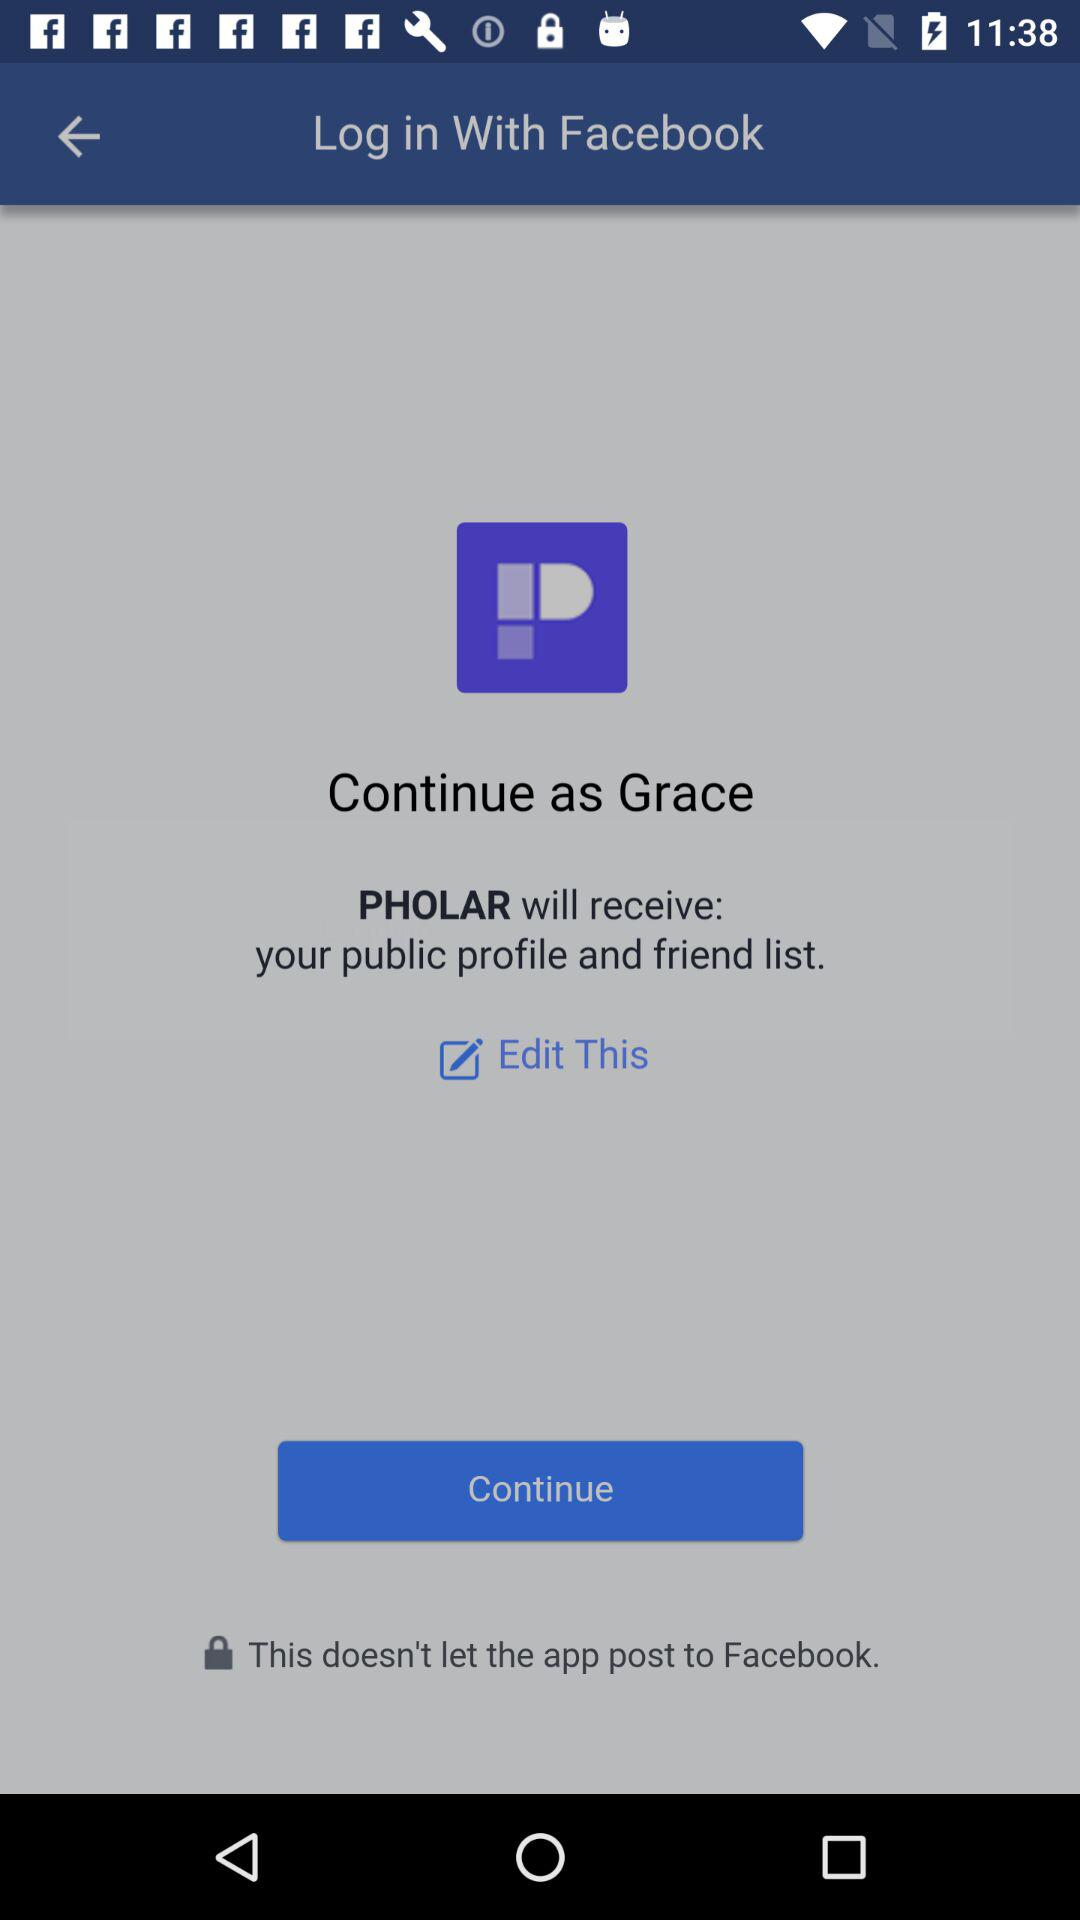Which information will "PHOLAR" receive? "PHOLAR" will receive your public profile and friend list. 